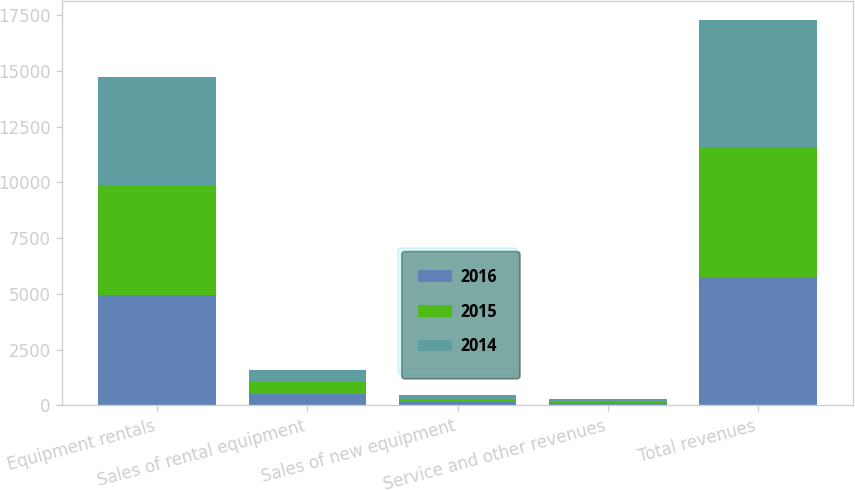Convert chart to OTSL. <chart><loc_0><loc_0><loc_500><loc_500><stacked_bar_chart><ecel><fcel>Equipment rentals<fcel>Sales of rental equipment<fcel>Sales of new equipment<fcel>Service and other revenues<fcel>Total revenues<nl><fcel>2016<fcel>4941<fcel>496<fcel>144<fcel>102<fcel>5762<nl><fcel>2015<fcel>4949<fcel>538<fcel>157<fcel>94<fcel>5817<nl><fcel>2014<fcel>4819<fcel>544<fcel>149<fcel>88<fcel>5685<nl></chart> 